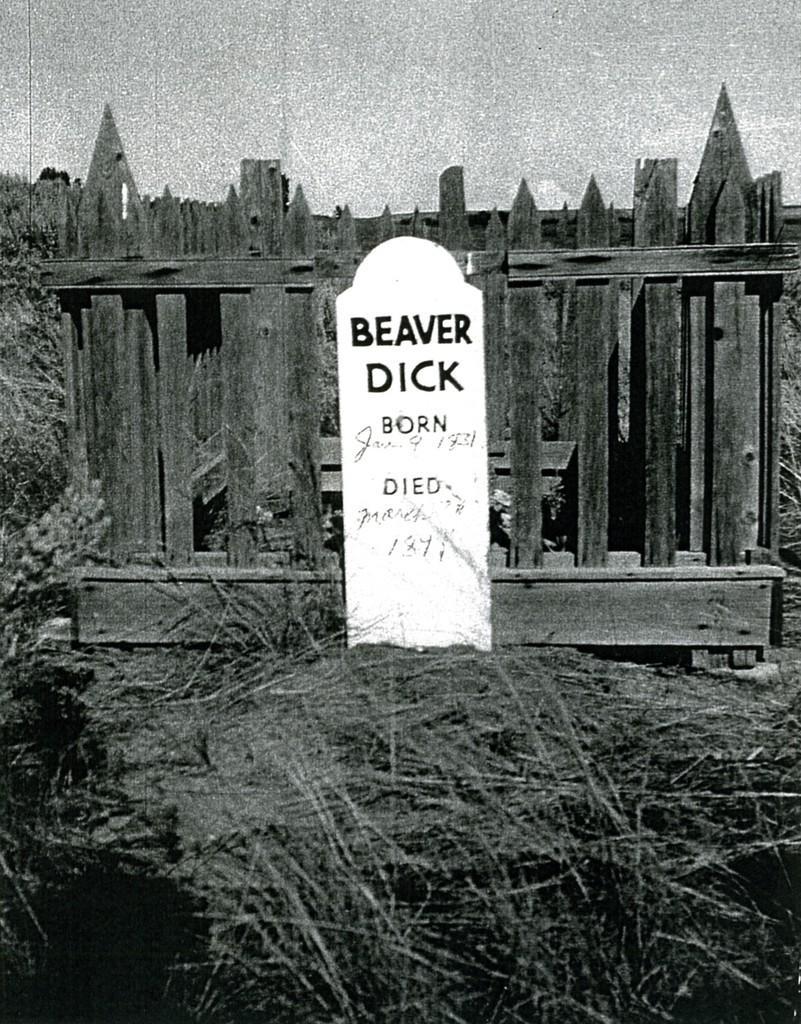How would you summarize this image in a sentence or two? This is a black and white image. In this image we can see a tomb and some text on the stone. On the backside we can see a fence and the sky. 